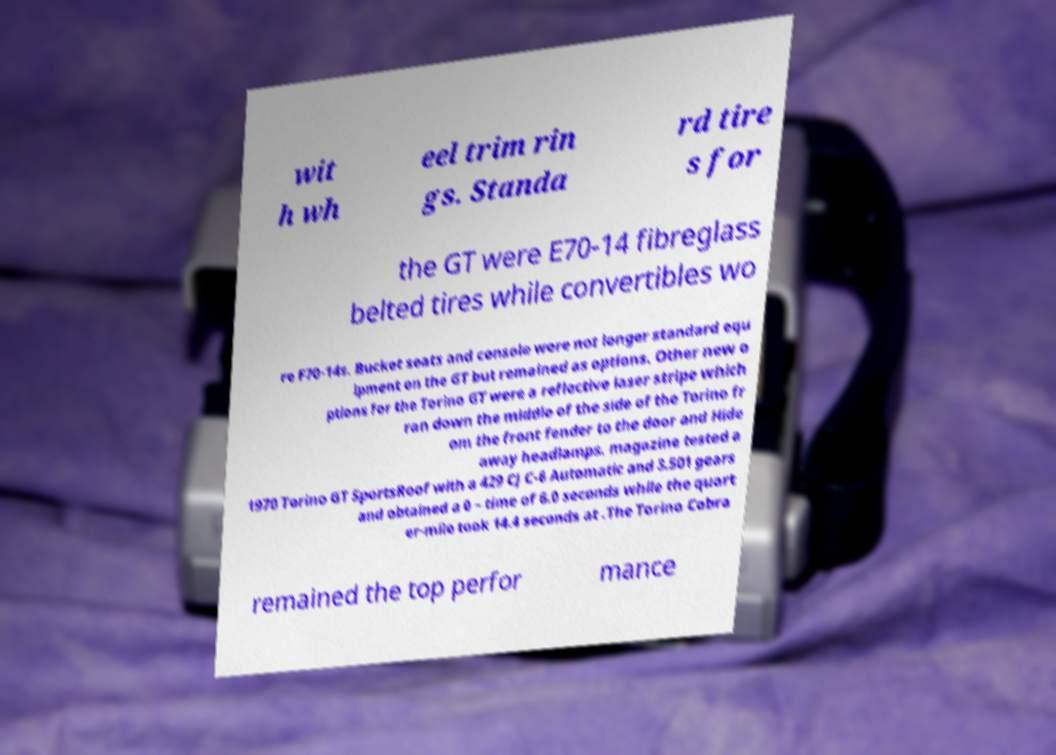Could you extract and type out the text from this image? wit h wh eel trim rin gs. Standa rd tire s for the GT were E70-14 fibreglass belted tires while convertibles wo re F70-14s. Bucket seats and console were not longer standard equ ipment on the GT but remained as options. Other new o ptions for the Torino GT were a reflective laser stripe which ran down the middle of the side of the Torino fr om the front fender to the door and Hide away headlamps. magazine tested a 1970 Torino GT SportsRoof with a 429 CJ C-6 Automatic and 3.501 gears and obtained a 0 – time of 6.0 seconds while the quart er-mile took 14.4 seconds at .The Torino Cobra remained the top perfor mance 